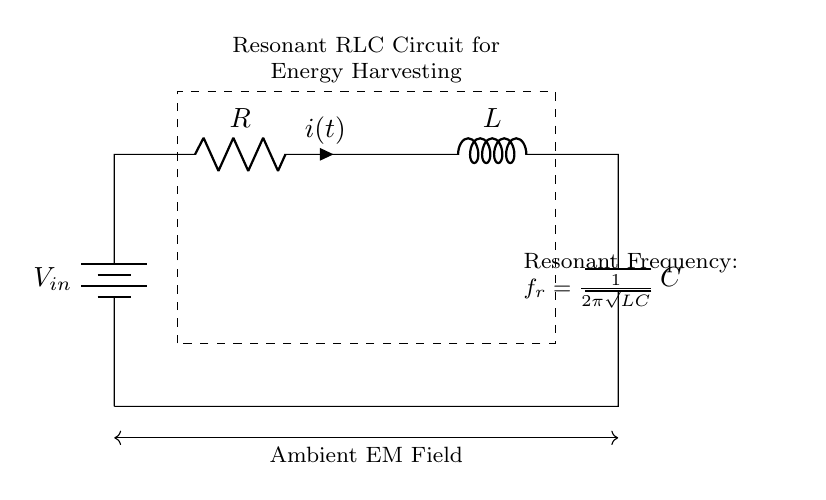What components are present in this circuit? The circuit consists of a resistor, inductor, and capacitor as indicated by the labels. These components are responsible for the resonant behavior of the circuit.
Answer: resistor, inductor, capacitor What does the rectangle represent in the circuit? The dashed rectangle denotes the specific area of interest for the resonant RLC circuit aimed at energy harvesting. It helps to highlight the circuit components involved in this application.
Answer: Resonant RLC Circuit What is the input of the circuit? The input voltage is indicated by the battery symbol labeled V in the circuit diagram. It supplies the required energy for the operation.
Answer: V in What is the formula for resonant frequency? The resonant frequency formula shown in the circuit is derived from the RLC circuit's characteristics, given as f_r = 1/(2π√(LC)), where L is inductance and C is capacitance. This relation shows how the frequency depends on these parameters.
Answer: f_r = 1/(2π√(LC)) If the inductor value is increased while keeping the capacitor the same, what happens to the resonant frequency? Increasing the inductance L in the resonant frequency formula f_r = 1/(2π√(LC)) results in a lower resonant frequency since the frequency is inversely proportional to the square root of L. This means the circuit would resonate at a lower frequency.
Answer: Decreases What effect does the resistor have on the circuit? The resistor R affects the damping of the circuit, influencing how oscillations decay over time. Higher resistance leads to greater energy loss and quicker dampening of oscillations. This is crucial for energy efficiency in the harvesting process.
Answer: Damping What is the role of the ambient electromagnetic field? The ambient electromagnetic field is the source of energy that the RLC circuit is designed to harvest, converting that energy into usable electrical power through resonance.
Answer: Energy source 